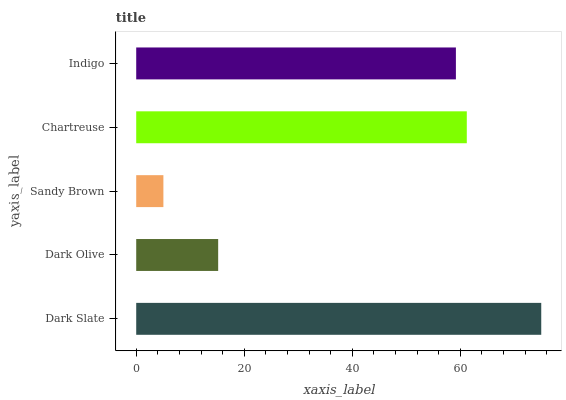Is Sandy Brown the minimum?
Answer yes or no. Yes. Is Dark Slate the maximum?
Answer yes or no. Yes. Is Dark Olive the minimum?
Answer yes or no. No. Is Dark Olive the maximum?
Answer yes or no. No. Is Dark Slate greater than Dark Olive?
Answer yes or no. Yes. Is Dark Olive less than Dark Slate?
Answer yes or no. Yes. Is Dark Olive greater than Dark Slate?
Answer yes or no. No. Is Dark Slate less than Dark Olive?
Answer yes or no. No. Is Indigo the high median?
Answer yes or no. Yes. Is Indigo the low median?
Answer yes or no. Yes. Is Chartreuse the high median?
Answer yes or no. No. Is Chartreuse the low median?
Answer yes or no. No. 